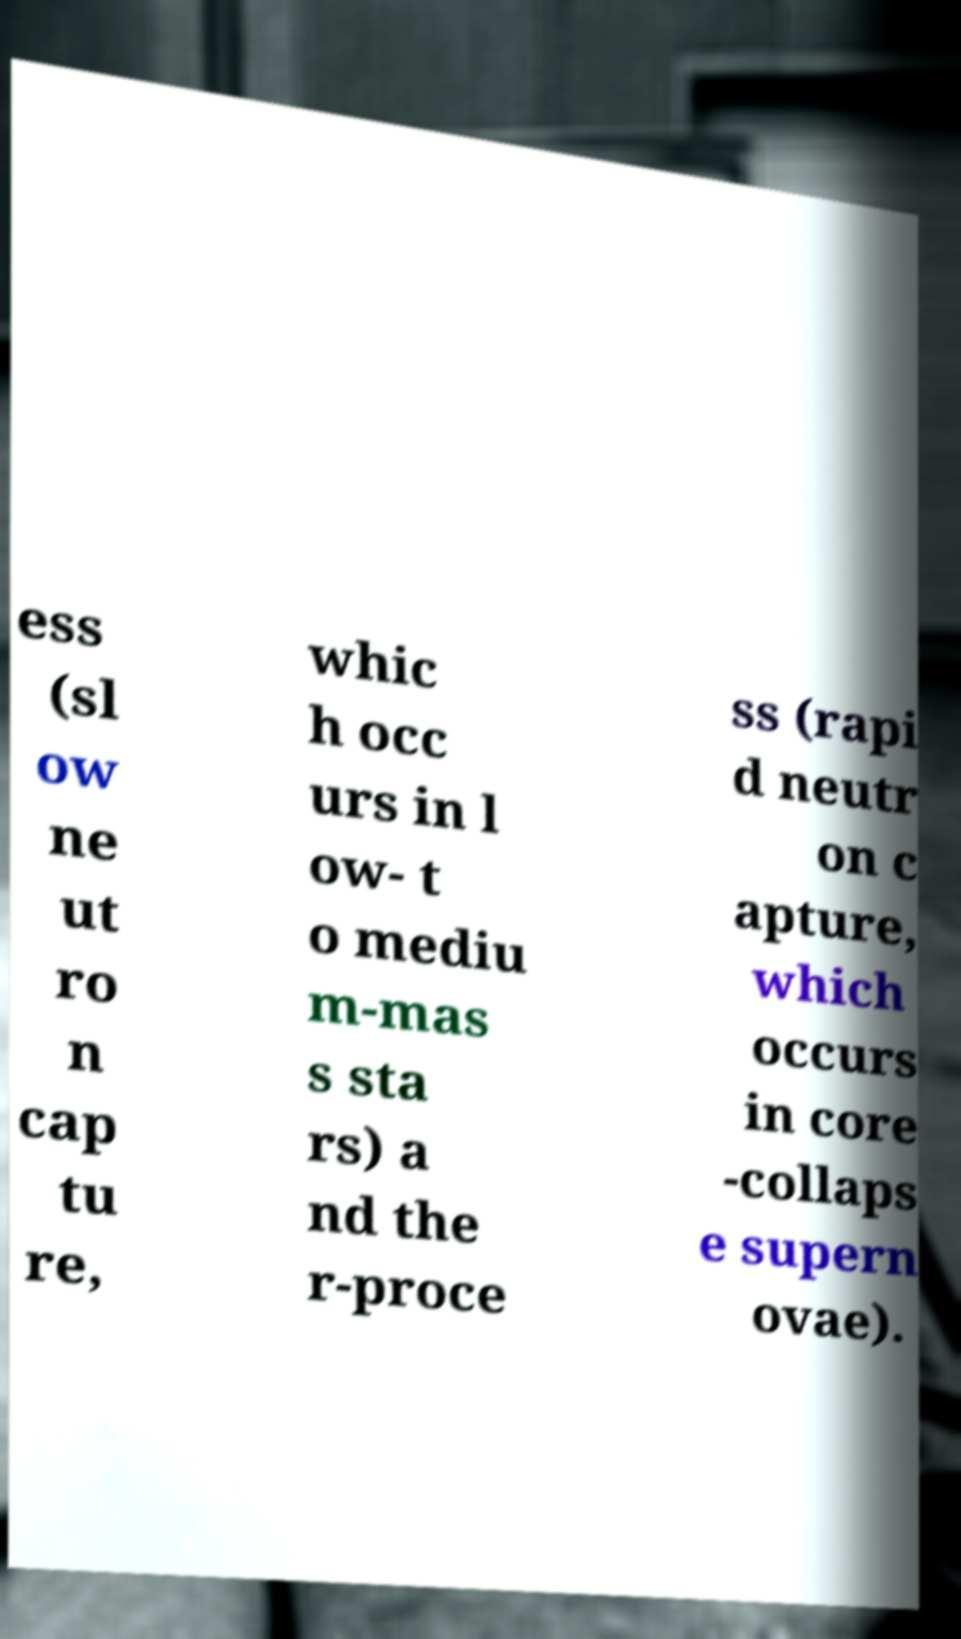Could you assist in decoding the text presented in this image and type it out clearly? ess (sl ow ne ut ro n cap tu re, whic h occ urs in l ow- t o mediu m-mas s sta rs) a nd the r-proce ss (rapi d neutr on c apture, which occurs in core -collaps e supern ovae). 